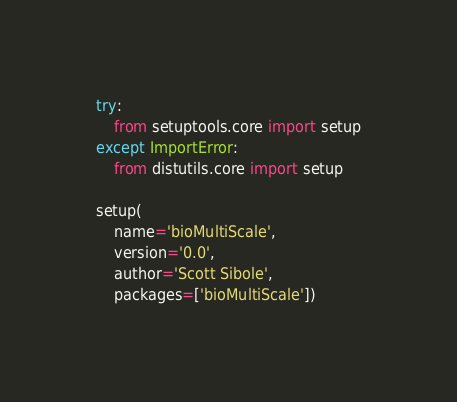Convert code to text. <code><loc_0><loc_0><loc_500><loc_500><_Python_>try:
    from setuptools.core import setup
except ImportError:
    from distutils.core import setup

setup(
    name='bioMultiScale',
    version='0.0',
    author='Scott Sibole',
    packages=['bioMultiScale'])
</code> 